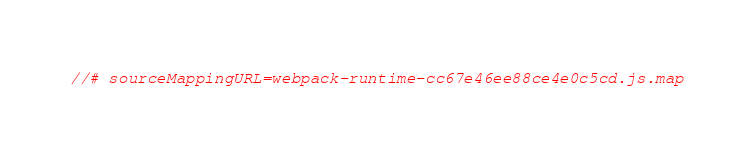<code> <loc_0><loc_0><loc_500><loc_500><_JavaScript_>//# sourceMappingURL=webpack-runtime-cc67e46ee88ce4e0c5cd.js.map</code> 